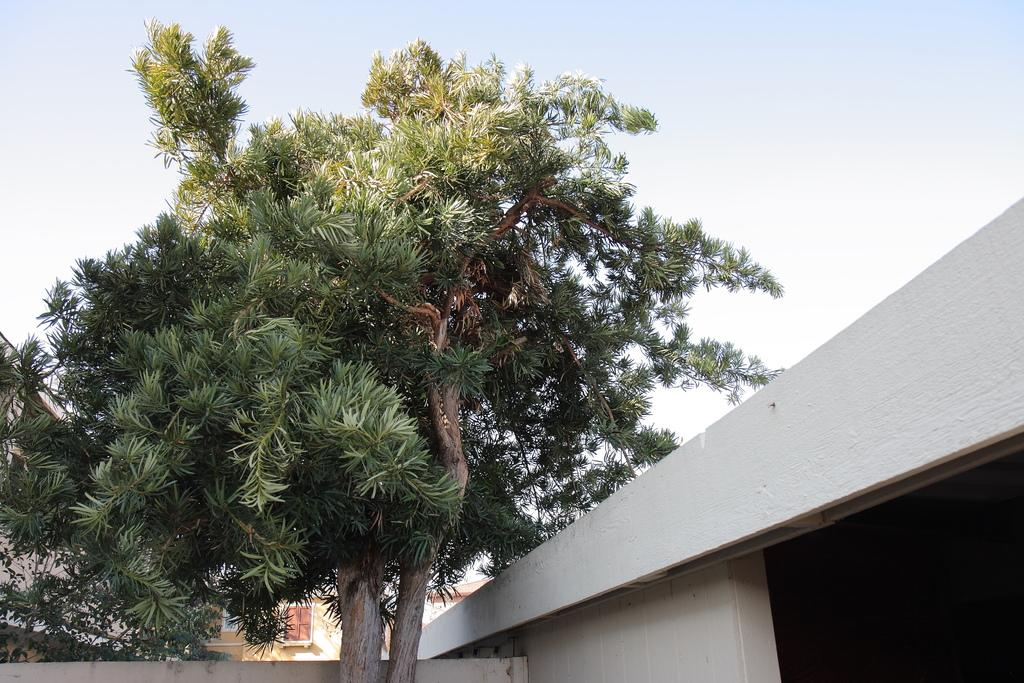What type of structure is visible in the image? There is a house in the image. What can be seen in front of the house? There are two tall trees in front of the house. What is located behind the trees? There is a building behind the trees. What other vegetation is present in the image? There are other plants on the left side of the image. How many cherries are hanging from the haircut of the person in the image? There is no person with a haircut or cherries present in the image. 